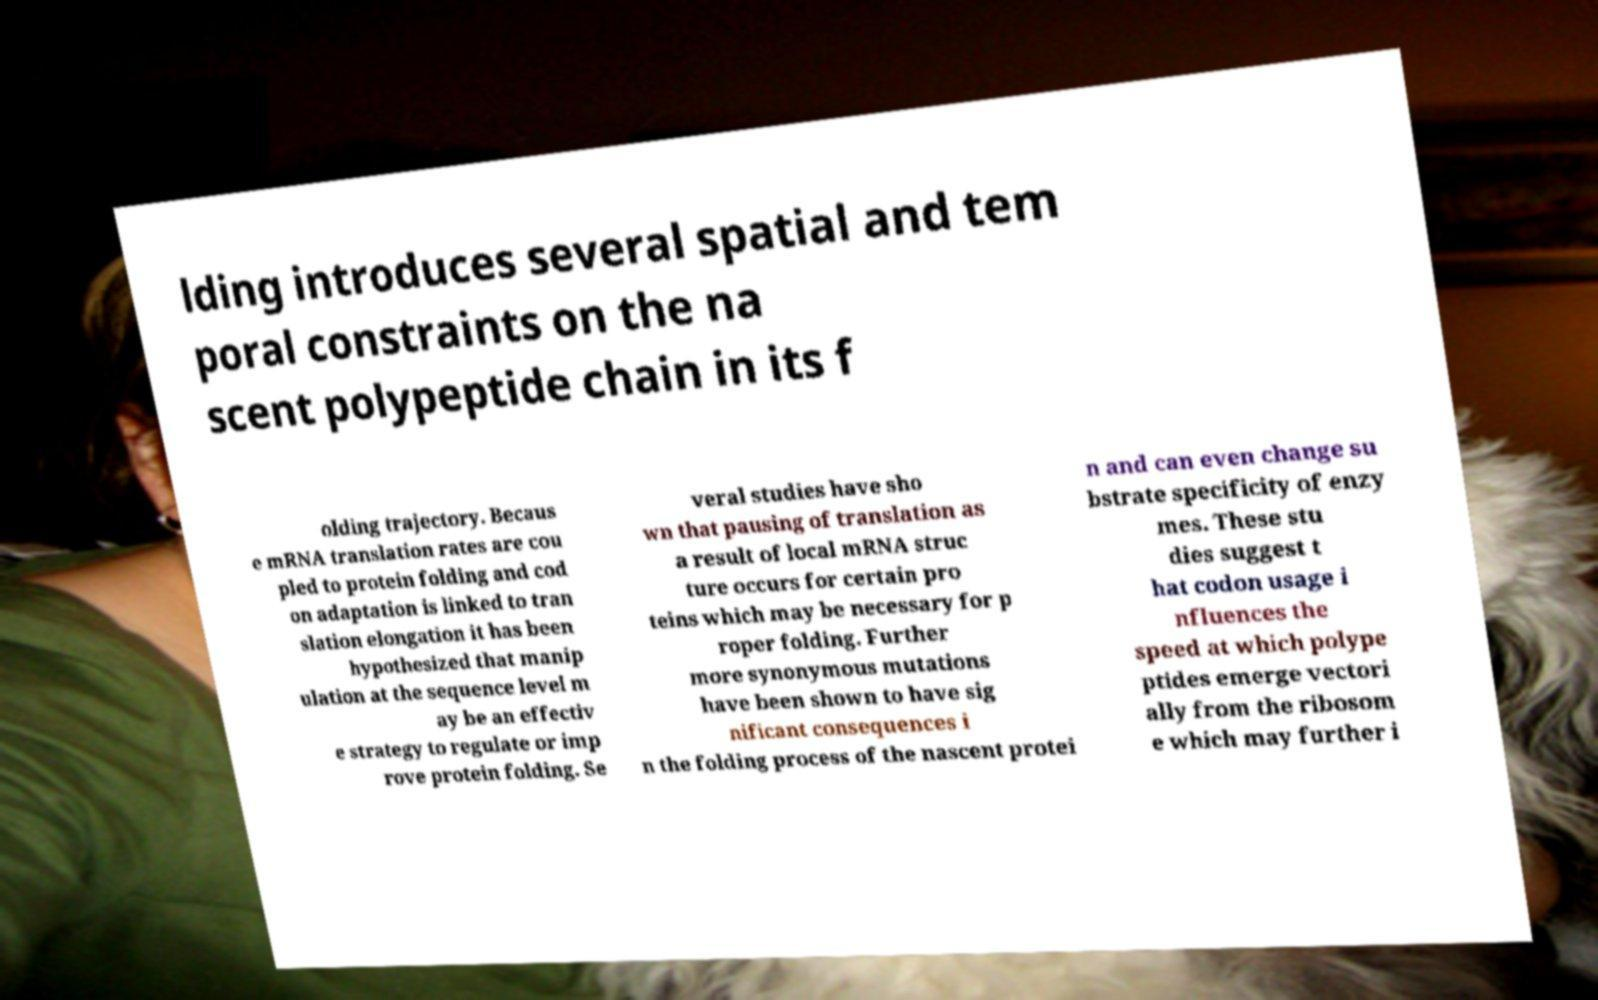I need the written content from this picture converted into text. Can you do that? lding introduces several spatial and tem poral constraints on the na scent polypeptide chain in its f olding trajectory. Becaus e mRNA translation rates are cou pled to protein folding and cod on adaptation is linked to tran slation elongation it has been hypothesized that manip ulation at the sequence level m ay be an effectiv e strategy to regulate or imp rove protein folding. Se veral studies have sho wn that pausing of translation as a result of local mRNA struc ture occurs for certain pro teins which may be necessary for p roper folding. Further more synonymous mutations have been shown to have sig nificant consequences i n the folding process of the nascent protei n and can even change su bstrate specificity of enzy mes. These stu dies suggest t hat codon usage i nfluences the speed at which polype ptides emerge vectori ally from the ribosom e which may further i 